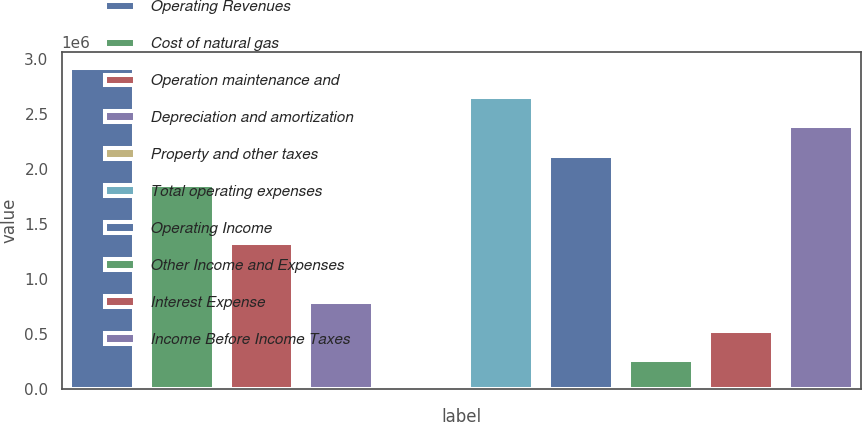<chart> <loc_0><loc_0><loc_500><loc_500><bar_chart><fcel>Operating Revenues<fcel>Cost of natural gas<fcel>Operation maintenance and<fcel>Depreciation and amortization<fcel>Property and other taxes<fcel>Total operating expenses<fcel>Operating Income<fcel>Other Income and Expenses<fcel>Interest Expense<fcel>Income Before Income Taxes<nl><fcel>2.91866e+06<fcel>1.85733e+06<fcel>1.32667e+06<fcel>796003<fcel>8<fcel>2.65332e+06<fcel>2.12266e+06<fcel>265340<fcel>530671<fcel>2.38799e+06<nl></chart> 